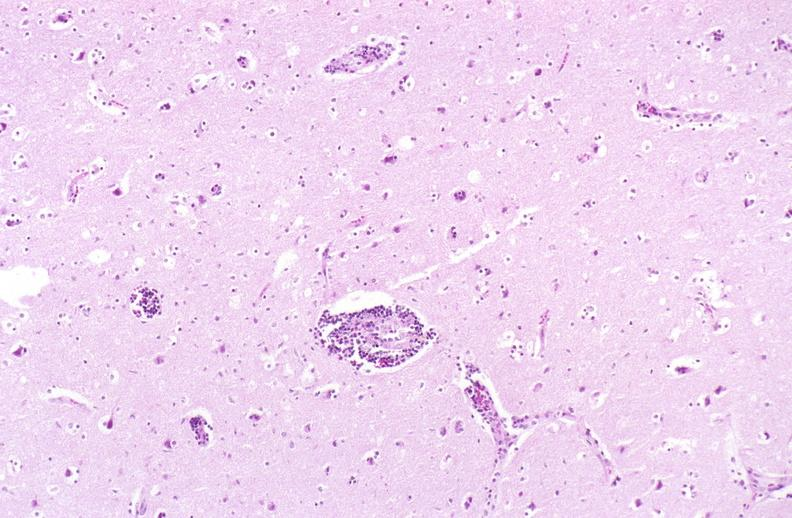what is present?
Answer the question using a single word or phrase. Nervous 